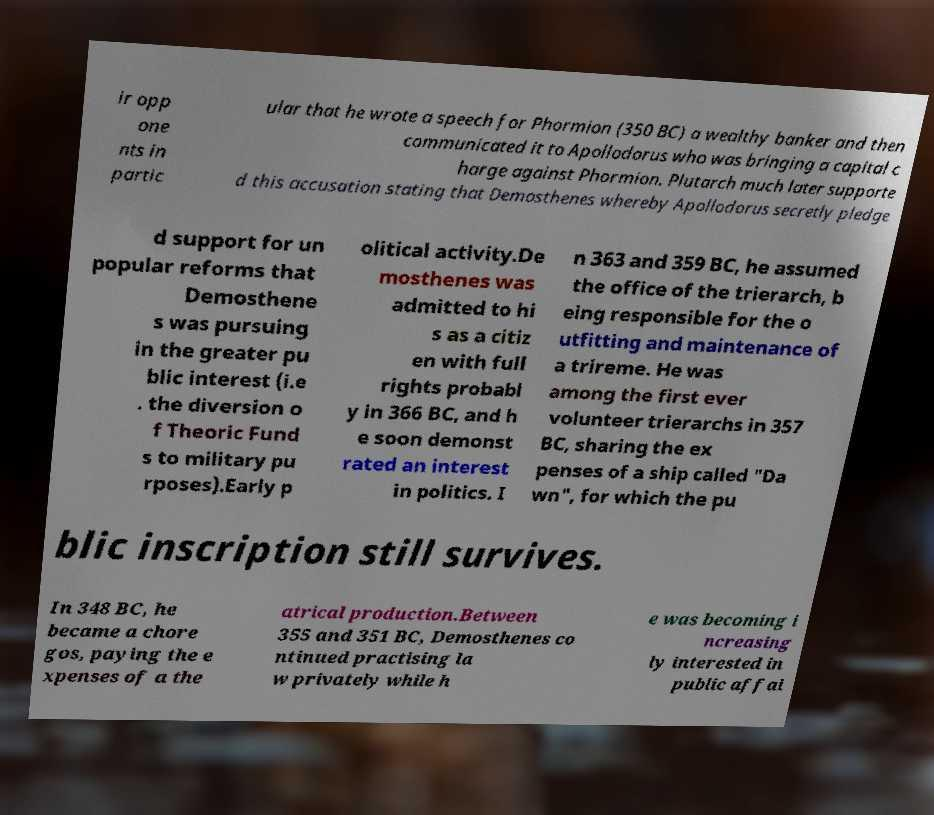Could you assist in decoding the text presented in this image and type it out clearly? ir opp one nts in partic ular that he wrote a speech for Phormion (350 BC) a wealthy banker and then communicated it to Apollodorus who was bringing a capital c harge against Phormion. Plutarch much later supporte d this accusation stating that Demosthenes whereby Apollodorus secretly pledge d support for un popular reforms that Demosthene s was pursuing in the greater pu blic interest (i.e . the diversion o f Theoric Fund s to military pu rposes).Early p olitical activity.De mosthenes was admitted to hi s as a citiz en with full rights probabl y in 366 BC, and h e soon demonst rated an interest in politics. I n 363 and 359 BC, he assumed the office of the trierarch, b eing responsible for the o utfitting and maintenance of a trireme. He was among the first ever volunteer trierarchs in 357 BC, sharing the ex penses of a ship called "Da wn", for which the pu blic inscription still survives. In 348 BC, he became a chore gos, paying the e xpenses of a the atrical production.Between 355 and 351 BC, Demosthenes co ntinued practising la w privately while h e was becoming i ncreasing ly interested in public affai 